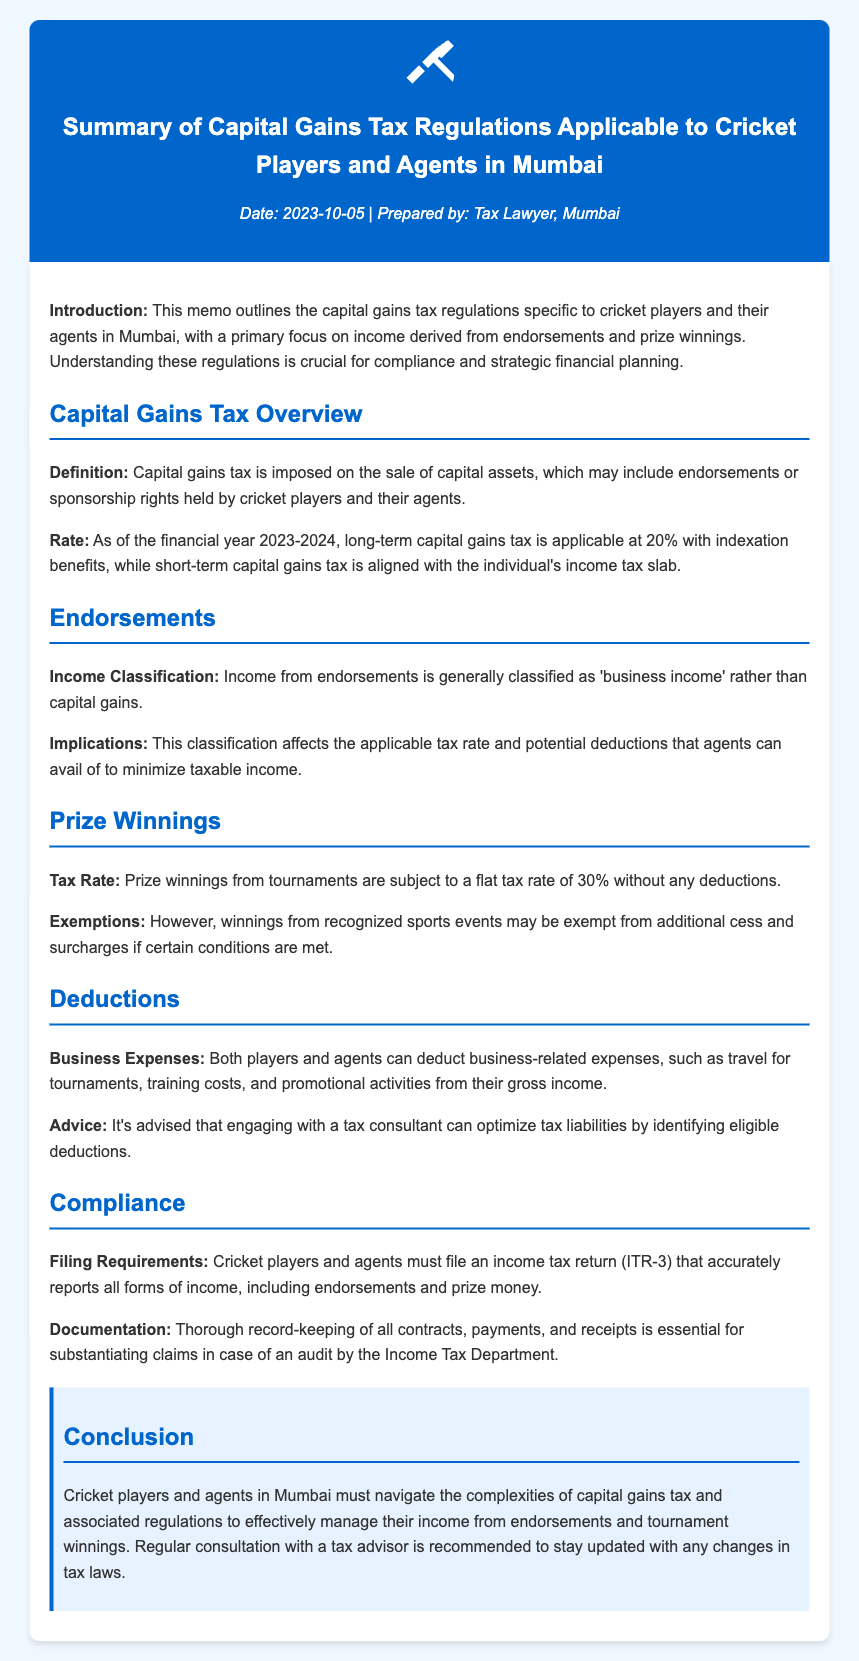What is the capital gains tax rate for long-term gains? The long-term capital gains tax rate is specified in the section on capital gains tax overview, stating that it is 20% with indexation benefits.
Answer: 20% What is classified as 'business income' in the context of cricket? The document specifies that income from endorsements is categorized as 'business income' rather than capital gains.
Answer: Business income What is the tax rate on prize winnings from tournaments? The tax rate for prize winnings is found in the prize winnings section, stating that it is a flat tax rate.
Answer: 30% What can be deducted from gross income according to the memo? The document highlights that players and agents can deduct business-related expenses such as travel for tournaments, training costs, and promotional activities.
Answer: Business-related expenses Which income tax return form must cricket players and agents file? The memo indicates that cricket players and agents must file income tax return ITR-3 as part of the compliance requirements.
Answer: ITR-3 What should players maintain for audit substantiation? The section on compliance states that thorough record-keeping of all contracts, payments, and receipts is essential for substantiating claims during an audit.
Answer: Contracts, payments, and receipts Where can cricket players seek advice to optimize tax liabilities? The deductions section advises that engaging with a tax consultant can help in optimizing tax liabilities by identifying eligible deductions.
Answer: Tax consultant What year is the capital gains tax overview for? The memo specifies that the applicable tax rate for the financial year is for 2023-2024.
Answer: 2023-2024 